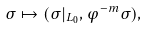<formula> <loc_0><loc_0><loc_500><loc_500>\sigma \mapsto ( \sigma | _ { L _ { 0 } } , \varphi ^ { - m } \sigma ) ,</formula> 